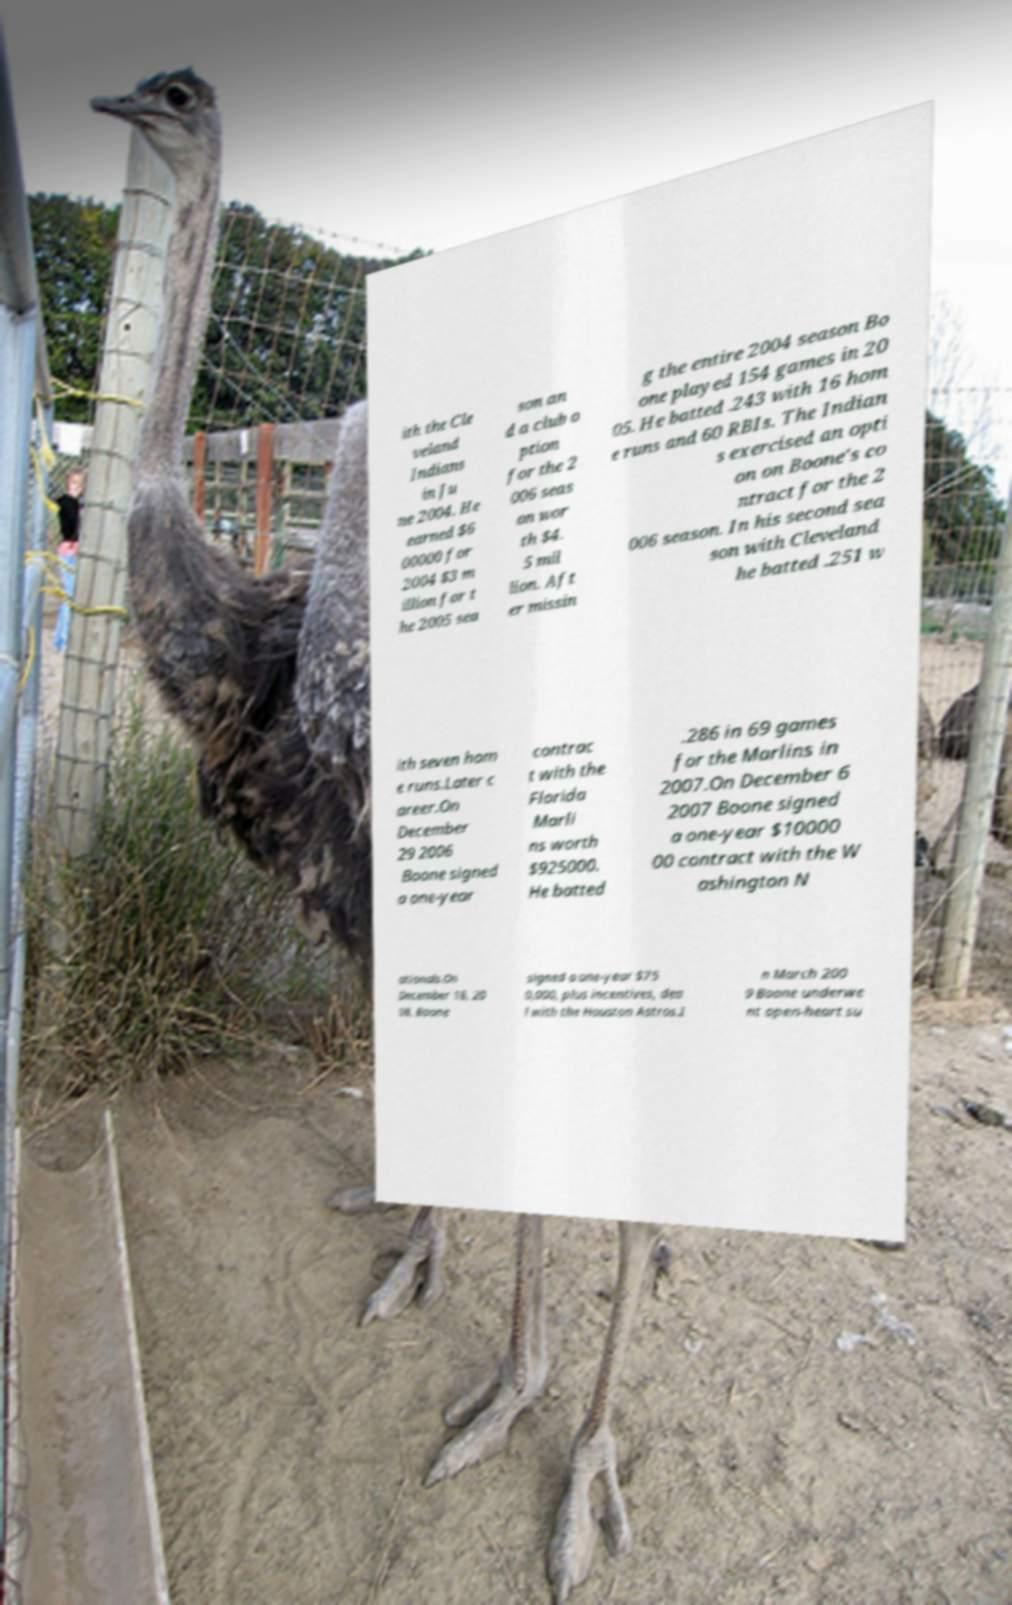I need the written content from this picture converted into text. Can you do that? ith the Cle veland Indians in Ju ne 2004. He earned $6 00000 for 2004 $3 m illion for t he 2005 sea son an d a club o ption for the 2 006 seas on wor th $4. 5 mil lion. Aft er missin g the entire 2004 season Bo one played 154 games in 20 05. He batted .243 with 16 hom e runs and 60 RBIs. The Indian s exercised an opti on on Boone's co ntract for the 2 006 season. In his second sea son with Cleveland he batted .251 w ith seven hom e runs.Later c areer.On December 29 2006 Boone signed a one-year contrac t with the Florida Marli ns worth $925000. He batted .286 in 69 games for the Marlins in 2007.On December 6 2007 Boone signed a one-year $10000 00 contract with the W ashington N ationals.On December 18, 20 08, Boone signed a one-year $75 0,000, plus incentives, dea l with the Houston Astros.I n March 200 9 Boone underwe nt open-heart su 